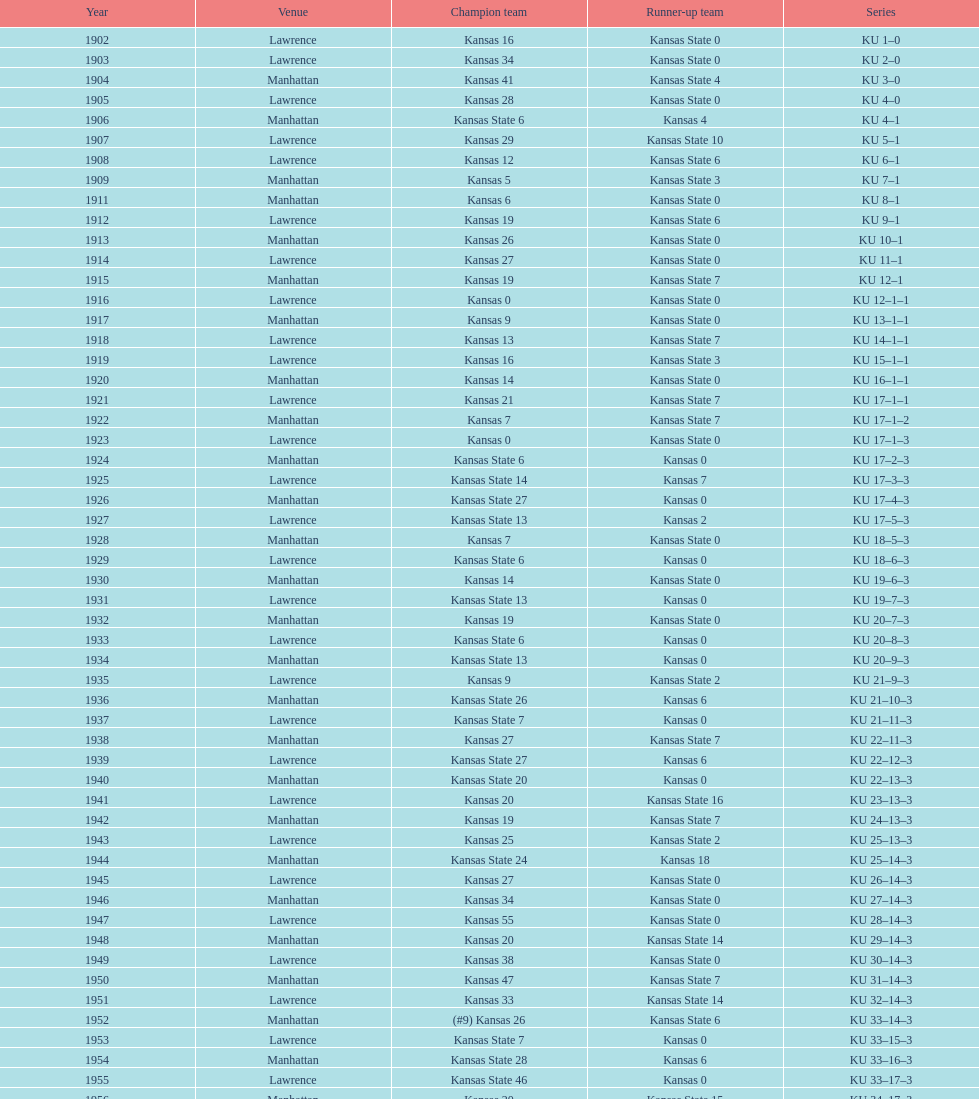What was the number of wins kansas state had in manhattan? 8. 